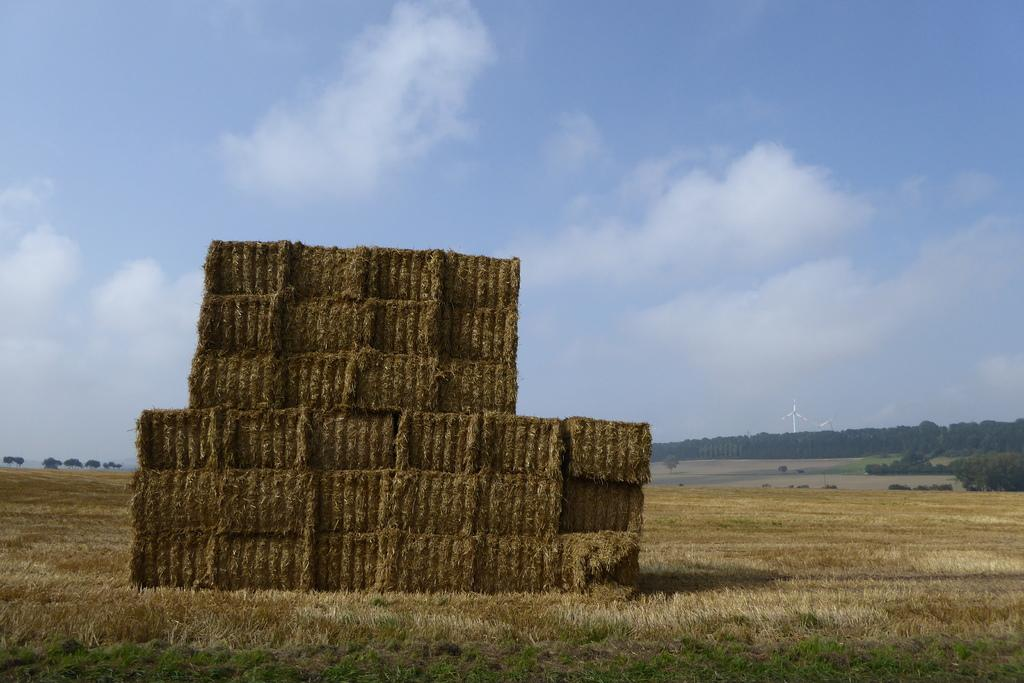What is present in the image that is typically used for animal bedding or feeding? There is hay in the image. What can be seen in the distance in the image? There are trees in the background of the image. What is visible in the sky in the background of the image? There are clouds in the sky in the background of the image. What type of bird can be seen flying through the door in the image? There is no bird or door present in the image; it only features hay and trees in the background. 